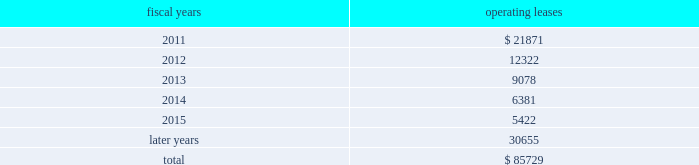The following is a schedule of future minimum rental payments required under long-term operating leases at october 30 , 2010 : fiscal years operating leases .
12 .
Commitments and contingencies from time to time in the ordinary course of the company 2019s business , various claims , charges and litigation are asserted or commenced against the company arising from , or related to , contractual matters , patents , trademarks , personal injury , environmental matters , product liability , insurance coverage and personnel and employment disputes .
As to such claims and litigation , the company can give no assurance that it will prevail .
The company does not believe that any current legal matters will have a material adverse effect on the company 2019s financial position , results of operations or cash flows .
13 .
Retirement plans the company and its subsidiaries have various savings and retirement plans covering substantially all employees .
The company maintains a defined contribution plan for the benefit of its eligible u.s .
Employees .
This plan provides for company contributions of up to 5% ( 5 % ) of each participant 2019s total eligible compensation .
In addition , the company contributes an amount equal to each participant 2019s pre-tax contribution , if any , up to a maximum of 3% ( 3 % ) of each participant 2019s total eligible compensation .
The total expense related to the defined contribution plan for u.s .
Employees was $ 20.5 million in fiscal 2010 , $ 21.5 million in fiscal 2009 and $ 22.6 million in fiscal 2008 .
The company also has various defined benefit pension and other retirement plans for certain non-u.s .
Employees that are consistent with local statutory requirements and practices .
The total expense related to the various defined benefit pension and other retirement plans for certain non-u.s .
Employees was $ 11.7 million in fiscal 2010 , $ 10.9 million in fiscal 2009 and $ 13.9 million in fiscal 2008 .
During fiscal 2009 , the measurement date of the plan 2019s funded status was changed from september 30 to the company 2019s fiscal year end .
Non-u.s .
Plan disclosures the company 2019s funding policy for its foreign defined benefit pension plans is consistent with the local requirements of each country .
The plans 2019 assets consist primarily of u.s .
And non-u.s .
Equity securities , bonds , property and cash .
The benefit obligations and related assets under these plans have been measured at october 30 , 2010 and october 31 , 2009 .
Analog devices , inc .
Notes to consolidated financial statements 2014 ( continued ) .
What was the total expense related to contribution plans from 2008 to 2010? 
Rationale: the way to find the answer is to take the total expense related contributions for both the us and non-us and add them together . then take all 3 years totals and add them together .
Computations: ((21.5 + 10.9) + ((22.6 + 13.9) + (20.5 + 11.7)))
Answer: 101.1. 